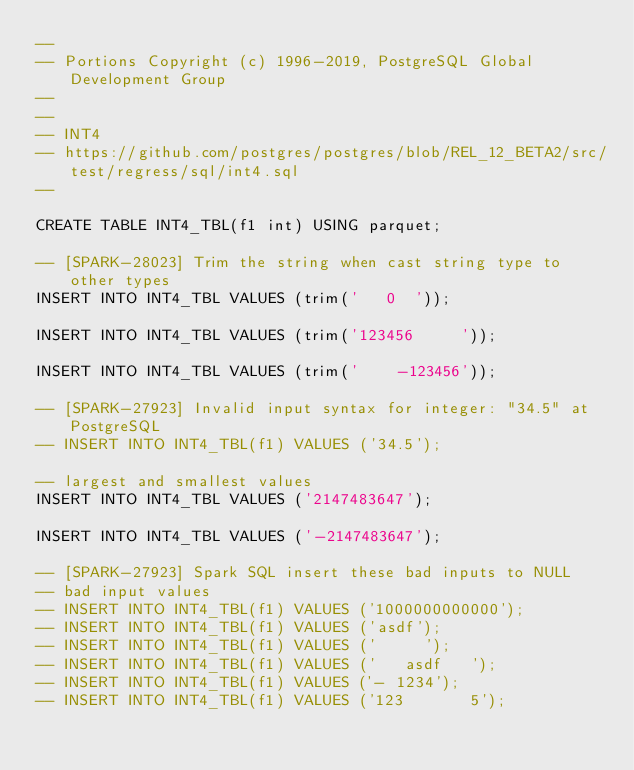Convert code to text. <code><loc_0><loc_0><loc_500><loc_500><_SQL_>--
-- Portions Copyright (c) 1996-2019, PostgreSQL Global Development Group
--
--
-- INT4
-- https://github.com/postgres/postgres/blob/REL_12_BETA2/src/test/regress/sql/int4.sql
--

CREATE TABLE INT4_TBL(f1 int) USING parquet;

-- [SPARK-28023] Trim the string when cast string type to other types
INSERT INTO INT4_TBL VALUES (trim('   0  '));

INSERT INTO INT4_TBL VALUES (trim('123456     '));

INSERT INTO INT4_TBL VALUES (trim('    -123456'));

-- [SPARK-27923] Invalid input syntax for integer: "34.5" at PostgreSQL
-- INSERT INTO INT4_TBL(f1) VALUES ('34.5');

-- largest and smallest values
INSERT INTO INT4_TBL VALUES ('2147483647');

INSERT INTO INT4_TBL VALUES ('-2147483647');

-- [SPARK-27923] Spark SQL insert these bad inputs to NULL
-- bad input values
-- INSERT INTO INT4_TBL(f1) VALUES ('1000000000000');
-- INSERT INTO INT4_TBL(f1) VALUES ('asdf');
-- INSERT INTO INT4_TBL(f1) VALUES ('     ');
-- INSERT INTO INT4_TBL(f1) VALUES ('   asdf   ');
-- INSERT INTO INT4_TBL(f1) VALUES ('- 1234');
-- INSERT INTO INT4_TBL(f1) VALUES ('123       5');</code> 